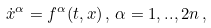<formula> <loc_0><loc_0><loc_500><loc_500>\dot { x } ^ { \alpha } = f ^ { \alpha } ( t , x ) \, , \, \alpha = 1 , . . , 2 n \, ,</formula> 